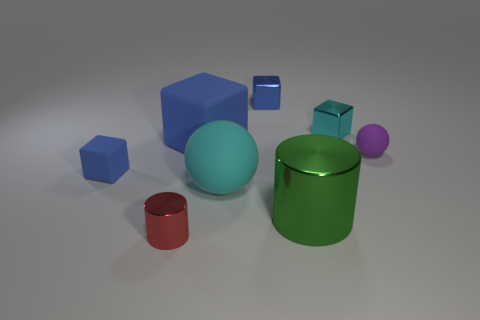Subtract all blue blocks. How many were subtracted if there are1blue blocks left? 2 Subtract all big blue blocks. How many blocks are left? 3 Subtract all blue blocks. How many blocks are left? 1 Add 1 tiny red matte things. How many objects exist? 9 Subtract all cylinders. How many objects are left? 6 Subtract all tiny metal cylinders. Subtract all small purple spheres. How many objects are left? 6 Add 5 small cyan metallic things. How many small cyan metallic things are left? 6 Add 2 green metal cylinders. How many green metal cylinders exist? 3 Subtract 0 yellow balls. How many objects are left? 8 Subtract 1 cylinders. How many cylinders are left? 1 